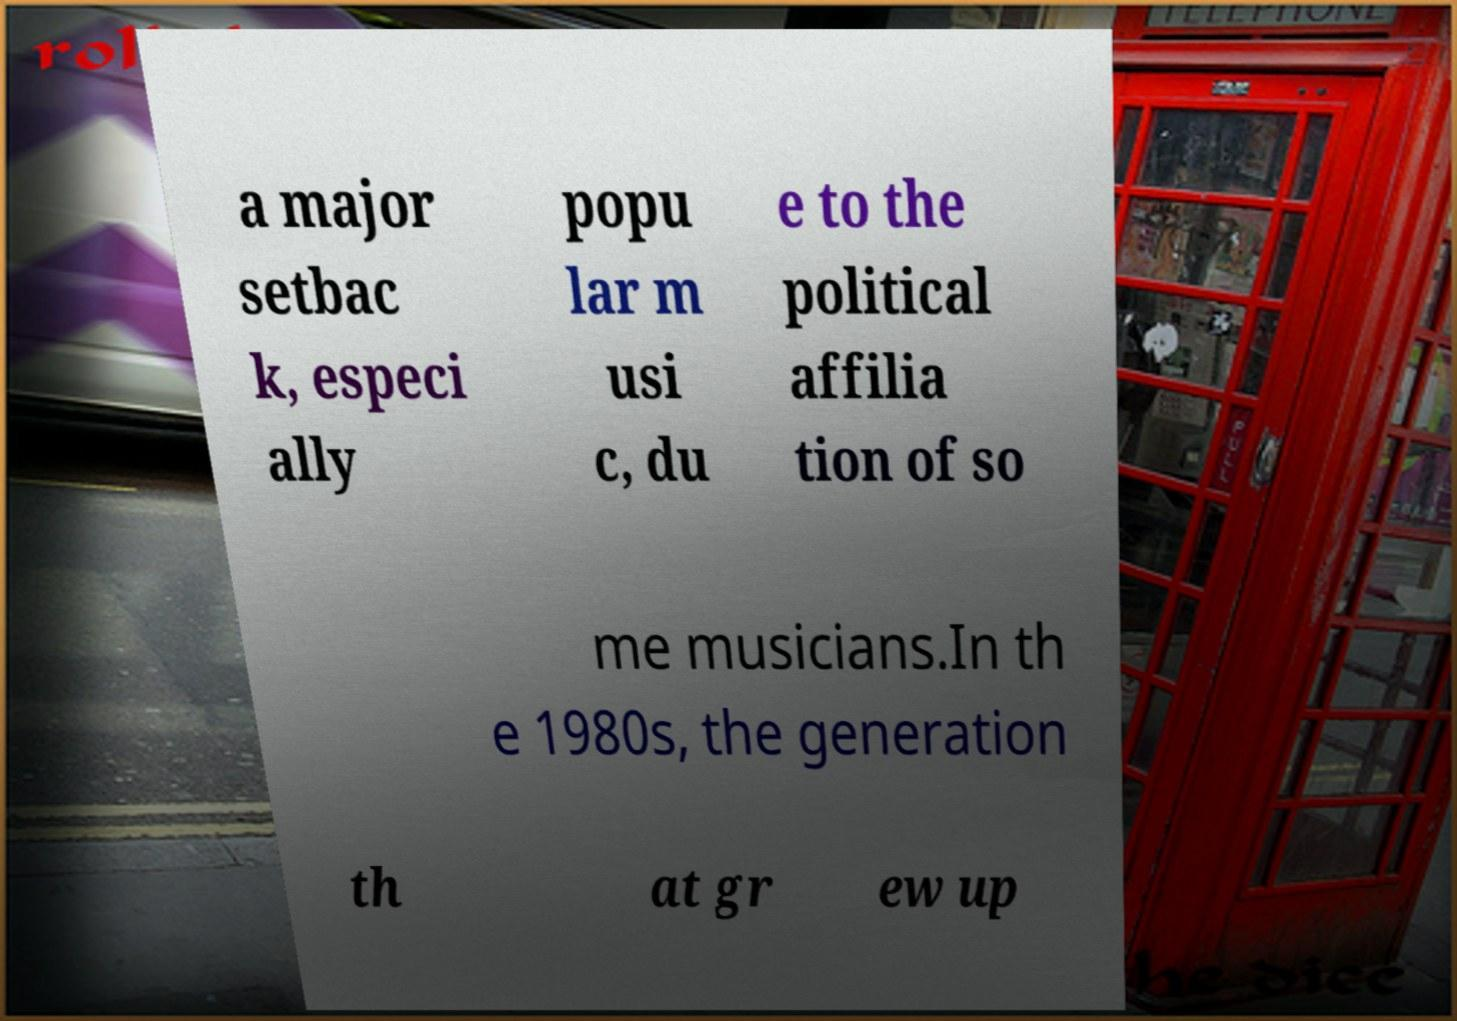Could you extract and type out the text from this image? a major setbac k, especi ally popu lar m usi c, du e to the political affilia tion of so me musicians.In th e 1980s, the generation th at gr ew up 